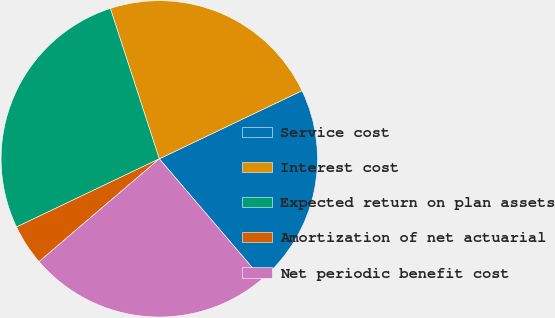Convert chart to OTSL. <chart><loc_0><loc_0><loc_500><loc_500><pie_chart><fcel>Service cost<fcel>Interest cost<fcel>Expected return on plan assets<fcel>Amortization of net actuarial<fcel>Net periodic benefit cost<nl><fcel>20.83%<fcel>22.92%<fcel>27.08%<fcel>4.17%<fcel>25.0%<nl></chart> 